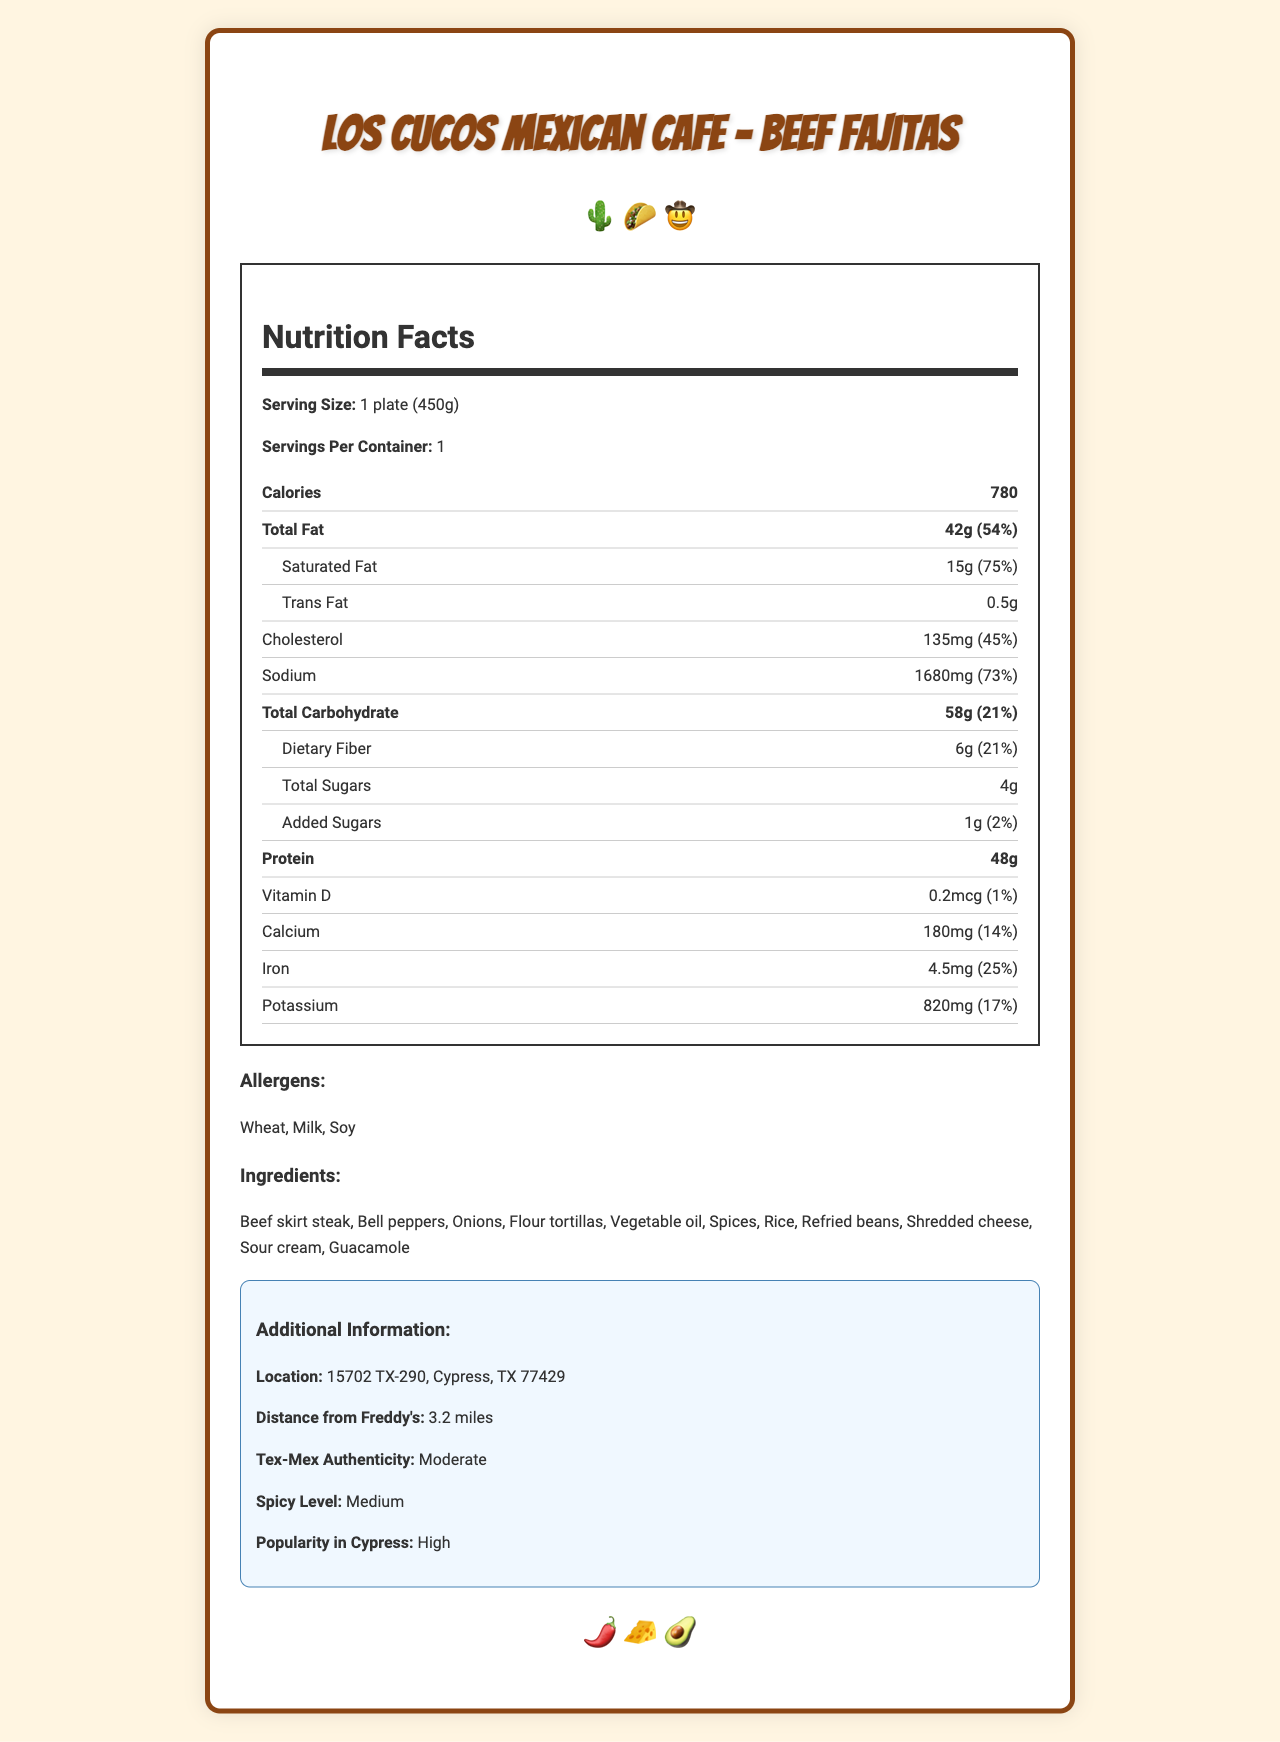what is the serving size for the Beef Fajitas? The document specifies the serving size as 1 plate (450g) right below the title.
Answer: 1 plate (450g) how many calories are in a serving of Beef Fajitas? The document lists calories per serving as 780 in the nutrition label section.
Answer: 780 What is the amount of saturated fat in the Beef Fajitas? In the nutrition label under the Total Fat section, it mentions the saturated fat amount as 15g.
Answer: 15g List three ingredients found in the Beef Fajitas The ingredients list includes Beef skirt steak, Bell peppers, Onions, Flour tortillas, etc.
Answer: Beef skirt steak, Flour tortillas, Bell peppers what allergens are present in the Beef Fajitas? The allergens section in the document lists Wheat, Milk, and Soy.
Answer: Wheat, Milk, Soy How much dietary fiber is in a serving of Beef Fajitas? A. 4g B. 6g C. 8g D. 10g The dietary fiber amount is 6g which is mentioned in the nutrition label under Total Carbohydrate.
Answer: B. 6g Which of the following has the highest Daily Value percentage? A. Sodium B. Protein C. Vitamin D D. Potassium Sodium has a Daily Value percentage of 73%, which is the highest among the listed nutrients.
Answer: A. Sodium Does the Beef Fajitas dish contain any added sugars? The nutrition label shows that the dish contains 1g of added sugars.
Answer: Yes Summarize the main nutritional content and additional info of the Beef Fajitas The summary captures the key nutritional facts and highlights from the additional information section, providing an overall picture of the dish's nutritional content and relevance to the locality.
Answer: The Beef Fajitas from Los Cucos Mexican Cafe has a serving size of 1 plate (450g), containing 780 calories, 42g of total fat, and 48g of protein. It is moderately authentic Tex-Mex with a medium spicy level. The dish is popular in Cypress and the restaurant is 3.2 miles from Freddy's. Major allergens present include Wheat, Milk, and Soy. Where is Los Cucos Mexican Cafe located in Cypress? The additional information section specifies the restaurant’s location.
Answer: 15702 TX-290, Cypress, TX 77429 What is the popularity level of Beef Fajitas in Cypress? The document states "High" popularity in the additional information section.
Answer: High How far is Los Cucos Mexican Cafe from Freddy's? The additional information section states that the distance from Freddy's is 3.2 miles.
Answer: 3.2 miles Can we determine the amount of Vitamin C in the Beef Fajitas? The document does not provide any information about Vitamin C content.
Answer: Cannot be determined What is the Iron content in terms of daily value percentage? The document indicates that the Iron content is 4.5mg, which is 25% of the daily value.
Answer: 25% 